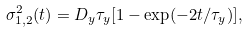Convert formula to latex. <formula><loc_0><loc_0><loc_500><loc_500>\sigma _ { 1 , 2 } ^ { 2 } ( t ) = D _ { y } \tau _ { y } [ 1 - \exp ( - 2 t / \tau _ { y } ) ] ,</formula> 